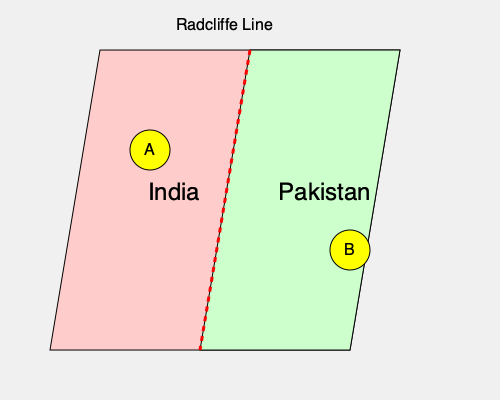Based on the map showing the partition of British India in 1947, which region (A or B) would likely have experienced a greater impact on women's rights due to the newly formed international border? To answer this question, we need to analyze the map and consider the implications of the partition on women's rights:

1. The map shows the division of British India into India (left) and Pakistan (right) along the Radcliffe Line.

2. Region A is located in India, relatively far from the new border.

3. Region B is located in Pakistan, close to the newly formed international border.

4. The partition led to massive population exchanges and displacement, particularly in areas near the border.

5. Women in border regions often faced greater challenges during and after partition, including:
   a) Increased vulnerability to violence and abduction
   b) Disruption of social and family structures
   c) Limited access to resources and support systems
   d) Challenges in maintaining property rights and inheritance

6. Region B, being closer to the border, would have likely experienced more significant population movements and social upheaval.

7. The proximity to the border in Region B would have made it more susceptible to cross-border tensions and conflicts, potentially affecting women's safety and mobility.

8. Region A, being further from the border, would have likely experienced relatively less direct impact from the partition-related violence and displacement.

Given these factors, Region B would likely have experienced a greater impact on women's rights due to its proximity to the newly formed international border and the associated challenges of partition.
Answer: Region B 